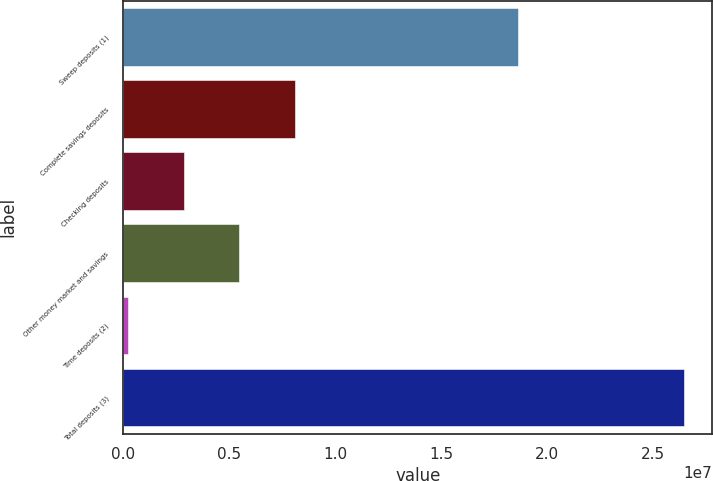Convert chart. <chart><loc_0><loc_0><loc_500><loc_500><bar_chart><fcel>Sweep deposits (1)<fcel>Complete savings deposits<fcel>Checking deposits<fcel>Other money market and savings<fcel>Time deposits (2)<fcel>Total deposits (3)<nl><fcel>1.8619e+07<fcel>8.09459e+06<fcel>2.84734e+06<fcel>5.47096e+06<fcel>223709<fcel>2.646e+07<nl></chart> 